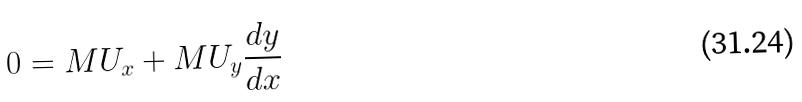<formula> <loc_0><loc_0><loc_500><loc_500>0 = M U _ { x } + M U _ { y } \frac { d y } { d x }</formula> 